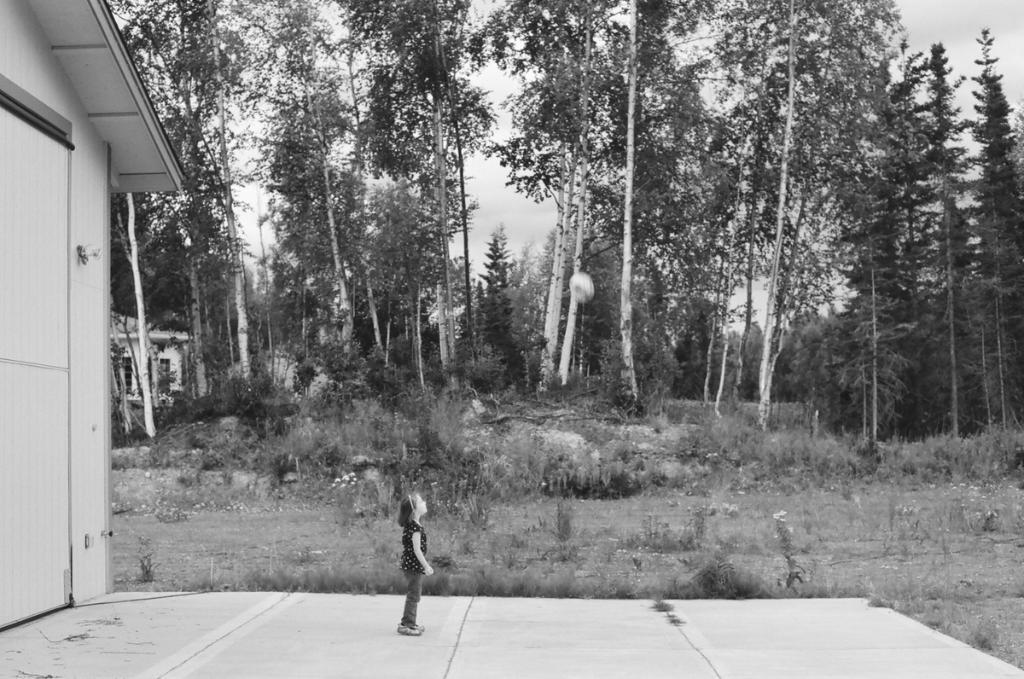In one or two sentences, can you explain what this image depicts? This is a black and white image. In this image we can see there is a little standing on the ground. On the left side of the image there is a house. In the background there are trees, grass and sky. 